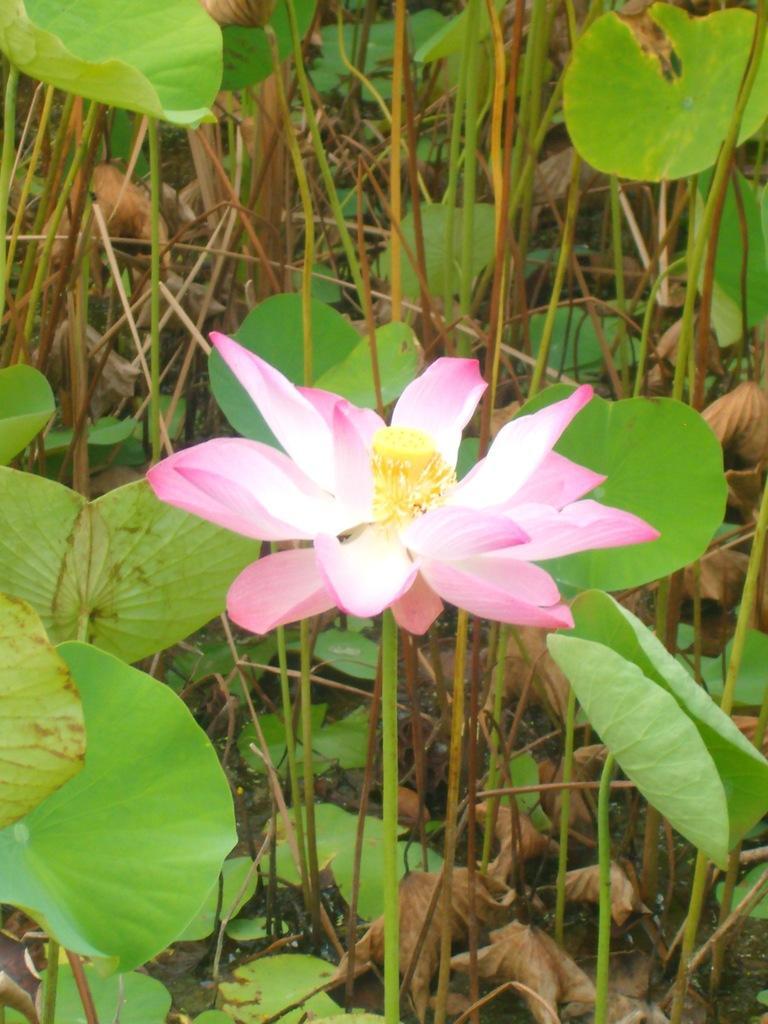Can you describe this image briefly? In this picture we can see the pink color flower in the middle. Behind there are some green leaves. 